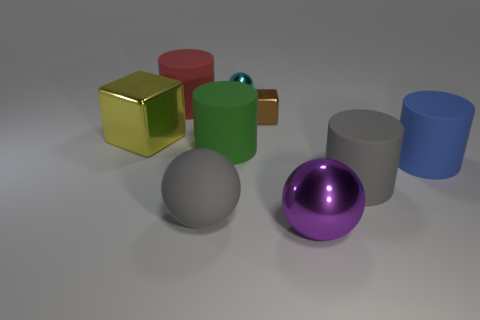Subtract all big spheres. How many spheres are left? 1 Add 1 red spheres. How many objects exist? 10 Subtract all blue cylinders. How many cylinders are left? 3 Subtract all balls. How many objects are left? 6 Subtract all brown balls. Subtract all cyan cubes. How many balls are left? 3 Add 7 blue things. How many blue things are left? 8 Add 3 purple metal cylinders. How many purple metal cylinders exist? 3 Subtract 1 purple balls. How many objects are left? 8 Subtract all yellow metal blocks. Subtract all big cyan things. How many objects are left? 8 